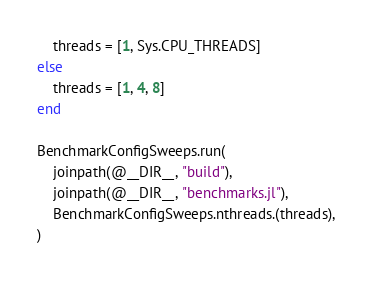Convert code to text. <code><loc_0><loc_0><loc_500><loc_500><_Julia_>    threads = [1, Sys.CPU_THREADS]
else
    threads = [1, 4, 8]
end

BenchmarkConfigSweeps.run(
    joinpath(@__DIR__, "build"),
    joinpath(@__DIR__, "benchmarks.jl"),
    BenchmarkConfigSweeps.nthreads.(threads),
)
</code> 